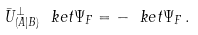Convert formula to latex. <formula><loc_0><loc_0><loc_500><loc_500>\bar { U } _ { ( A | B ) } ^ { \perp } \ k e t { \Psi _ { F } } = - \ k e t { \Psi _ { F } } \, .</formula> 